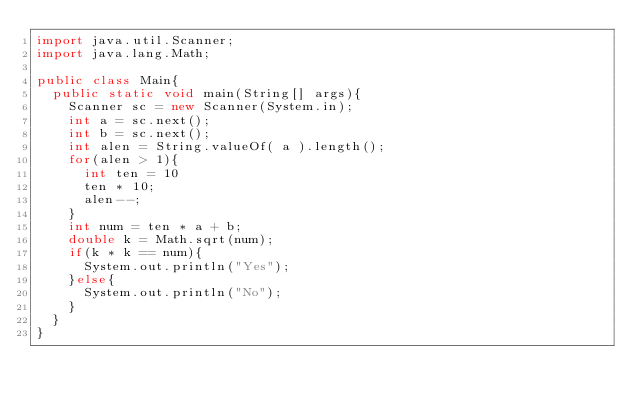<code> <loc_0><loc_0><loc_500><loc_500><_Java_>import java.util.Scanner;
import java.lang.Math;

public class Main{
  public static void main(String[] args){
    Scanner sc = new Scanner(System.in);
    int a = sc.next();
    int b = sc.next();
    int alen = String.valueOf( a ).length();
    for(alen > 1){
      int ten = 10
      ten * 10;
      alen--;
    }
    int num = ten * a + b;
    double k = Math.sqrt(num);
    if(k * k == num){
      System.out.println("Yes");
    }else{
      System.out.println("No");
    }
  }
}</code> 